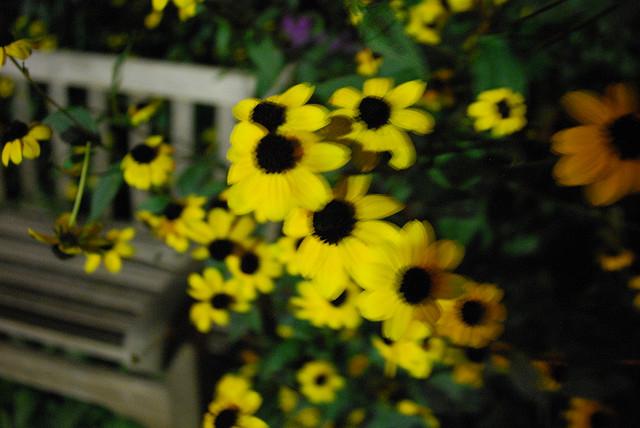What is in focus?
Write a very short answer. Flowers. What is the bench made of?
Be succinct. Wood. What kind of flowers are shown?
Quick response, please. Daisies. Is this picture clear?
Concise answer only. No. What type of flower is in the picture?
Quick response, please. Daisy. What type of flower is this?
Keep it brief. Daisy. 